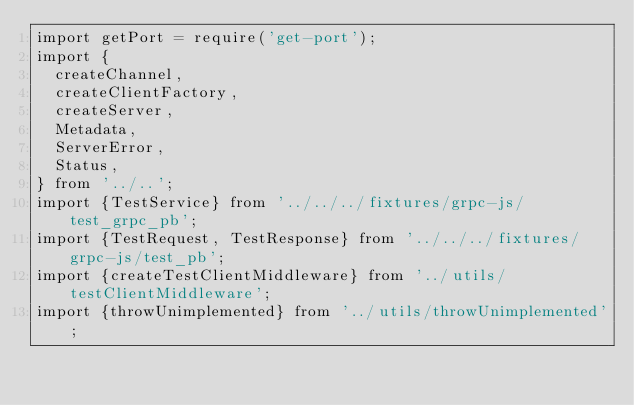<code> <loc_0><loc_0><loc_500><loc_500><_TypeScript_>import getPort = require('get-port');
import {
  createChannel,
  createClientFactory,
  createServer,
  Metadata,
  ServerError,
  Status,
} from '../..';
import {TestService} from '../../../fixtures/grpc-js/test_grpc_pb';
import {TestRequest, TestResponse} from '../../../fixtures/grpc-js/test_pb';
import {createTestClientMiddleware} from '../utils/testClientMiddleware';
import {throwUnimplemented} from '../utils/throwUnimplemented';
</code> 